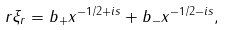Convert formula to latex. <formula><loc_0><loc_0><loc_500><loc_500>r \xi _ { r } = b _ { + } x ^ { - 1 / 2 + i s } + b _ { - } x ^ { - 1 / 2 - i s } ,</formula> 